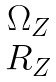Convert formula to latex. <formula><loc_0><loc_0><loc_500><loc_500>\begin{matrix} \Omega _ { Z } \\ R _ { Z } \end{matrix}</formula> 